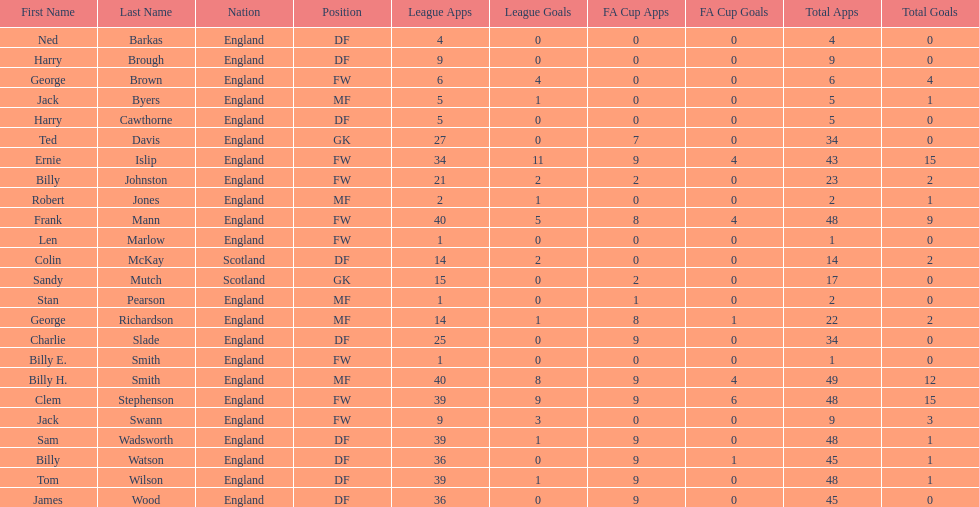Name the nation with the most appearances. England. 